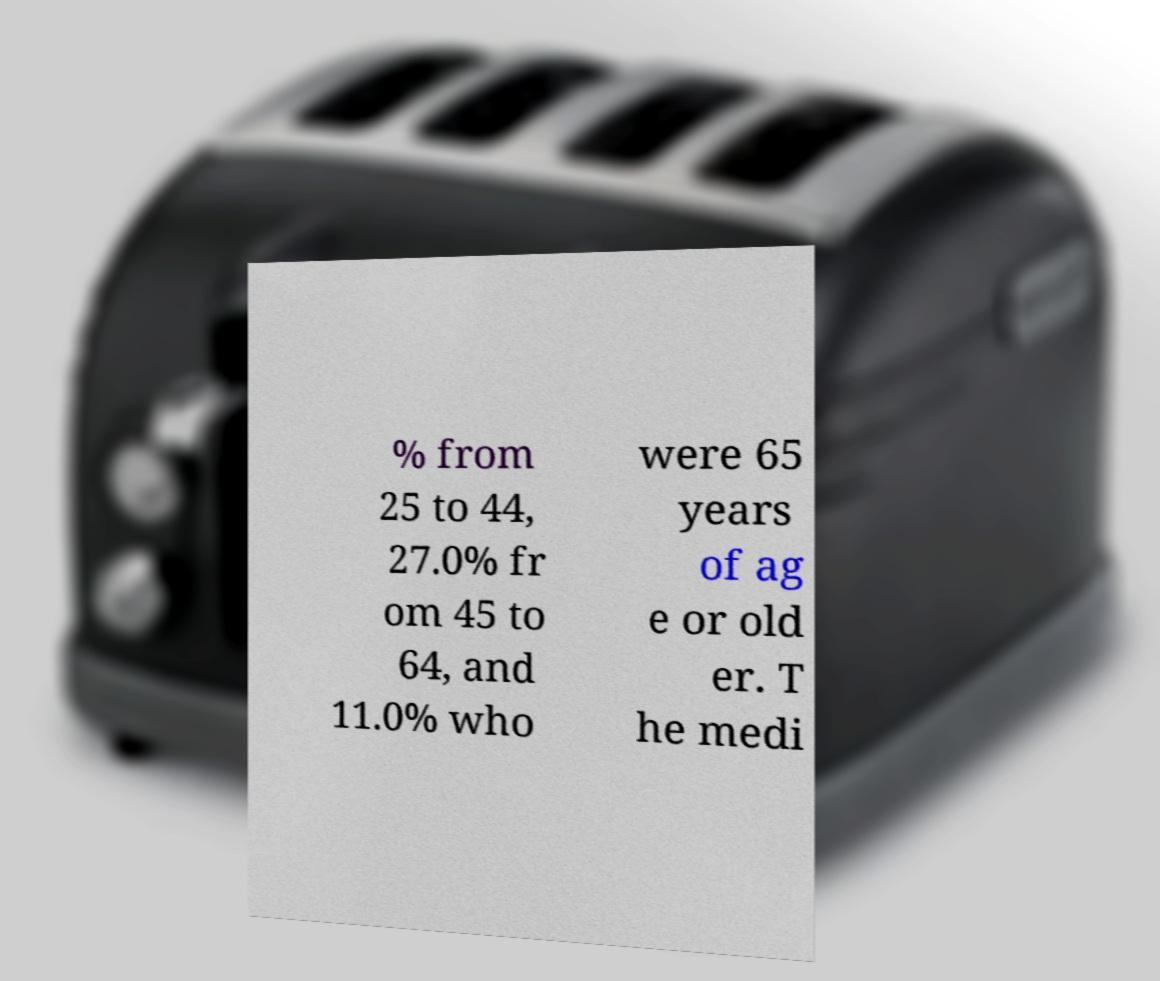Can you read and provide the text displayed in the image?This photo seems to have some interesting text. Can you extract and type it out for me? % from 25 to 44, 27.0% fr om 45 to 64, and 11.0% who were 65 years of ag e or old er. T he medi 